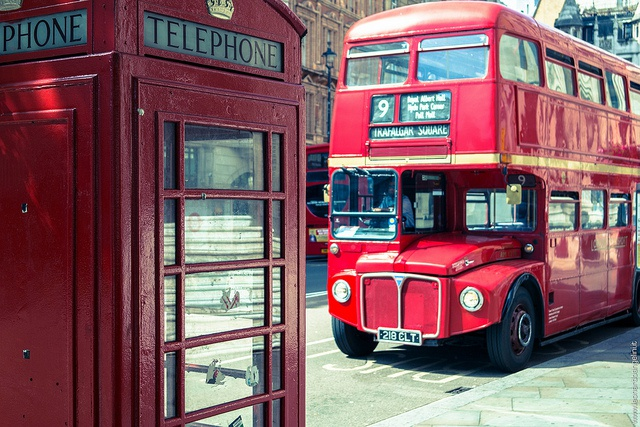Describe the objects in this image and their specific colors. I can see bus in teal, black, salmon, ivory, and brown tones, bus in teal, black, maroon, navy, and blue tones, and people in teal, blue, navy, and black tones in this image. 